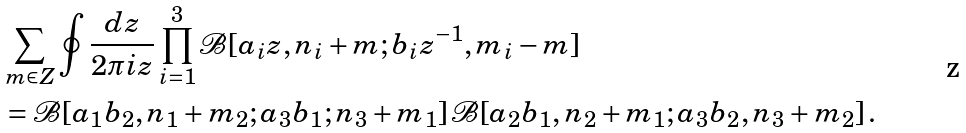Convert formula to latex. <formula><loc_0><loc_0><loc_500><loc_500>& \sum _ { m \in Z } \oint \frac { d z } { 2 \pi i z } \prod _ { i = 1 } ^ { 3 } { \mathcal { B } } [ a _ { i } z , n _ { i } + m ; b _ { i } z ^ { - 1 } , m _ { i } - m ] \\ & = { \mathcal { B } } [ a _ { 1 } b _ { 2 } , n _ { 1 } + m _ { 2 } ; a _ { 3 } b _ { 1 } ; n _ { 3 } + m _ { 1 } ] \, { \mathcal { B } } [ a _ { 2 } b _ { 1 } , n _ { 2 } + m _ { 1 } ; a _ { 3 } b _ { 2 } , n _ { 3 } + m _ { 2 } ] \, .</formula> 